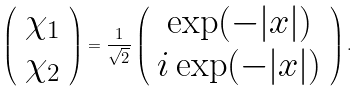<formula> <loc_0><loc_0><loc_500><loc_500>\left ( \begin{array} { c } \chi _ { 1 } \\ \chi _ { 2 } \end{array} \right ) = \frac { 1 } { \sqrt { 2 } } \left ( \begin{array} { c } \exp ( - | x | ) \\ i \exp ( - | x | ) \end{array} \right ) .</formula> 